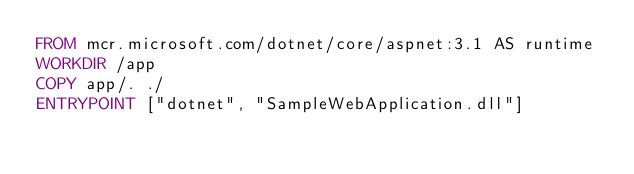Convert code to text. <code><loc_0><loc_0><loc_500><loc_500><_Dockerfile_>FROM mcr.microsoft.com/dotnet/core/aspnet:3.1 AS runtime
WORKDIR /app
COPY app/. ./
ENTRYPOINT ["dotnet", "SampleWebApplication.dll"]</code> 